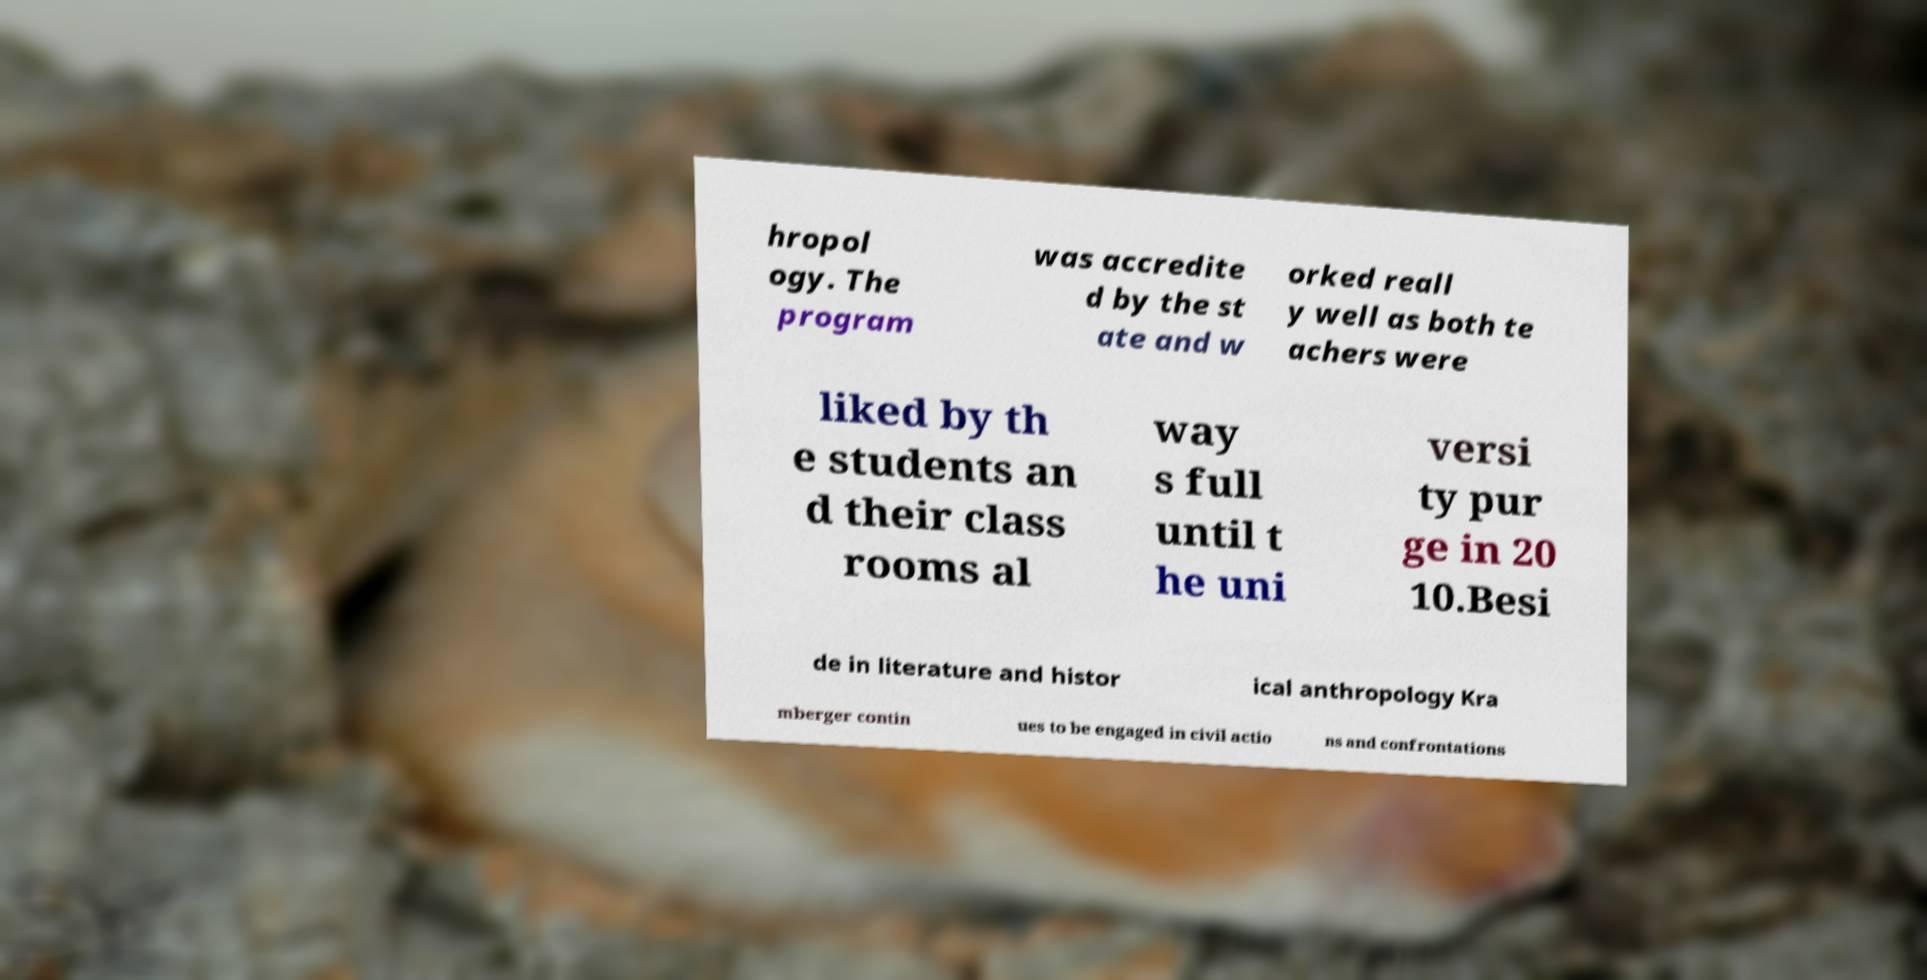Can you read and provide the text displayed in the image?This photo seems to have some interesting text. Can you extract and type it out for me? hropol ogy. The program was accredite d by the st ate and w orked reall y well as both te achers were liked by th e students an d their class rooms al way s full until t he uni versi ty pur ge in 20 10.Besi de in literature and histor ical anthropology Kra mberger contin ues to be engaged in civil actio ns and confrontations 